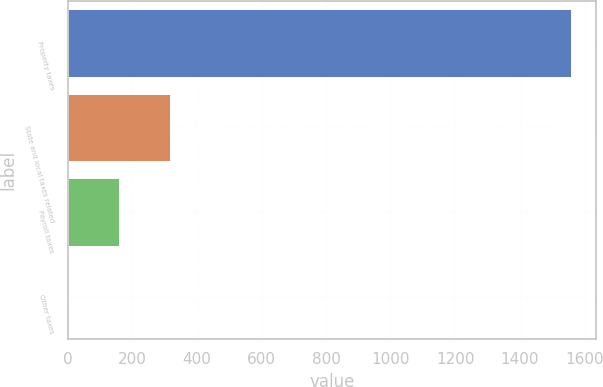Convert chart to OTSL. <chart><loc_0><loc_0><loc_500><loc_500><bar_chart><fcel>Property taxes<fcel>State and local taxes related<fcel>Payroll taxes<fcel>Other taxes<nl><fcel>1557<fcel>315.4<fcel>160.2<fcel>5<nl></chart> 